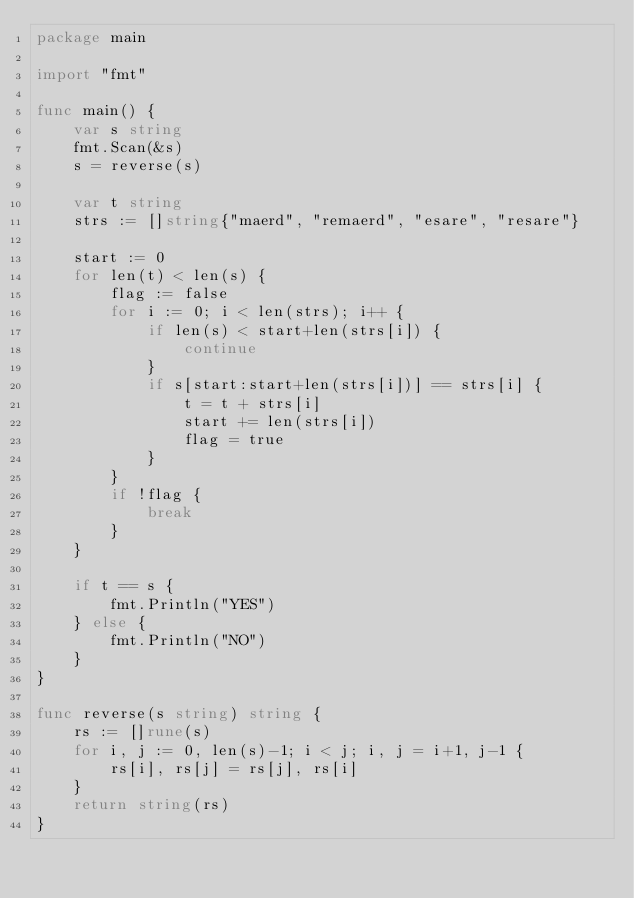Convert code to text. <code><loc_0><loc_0><loc_500><loc_500><_Go_>package main

import "fmt"

func main() {
	var s string
	fmt.Scan(&s)
	s = reverse(s)

	var t string
	strs := []string{"maerd", "remaerd", "esare", "resare"}

	start := 0
	for len(t) < len(s) {
		flag := false
		for i := 0; i < len(strs); i++ {
			if len(s) < start+len(strs[i]) {
				continue
			}
			if s[start:start+len(strs[i])] == strs[i] {
				t = t + strs[i]
				start += len(strs[i])
				flag = true
			}
		}
		if !flag {
			break
		}
	}

	if t == s {
		fmt.Println("YES")
	} else {
		fmt.Println("NO")
	}
}

func reverse(s string) string {
	rs := []rune(s)
	for i, j := 0, len(s)-1; i < j; i, j = i+1, j-1 {
		rs[i], rs[j] = rs[j], rs[i]
	}
	return string(rs)
}
</code> 